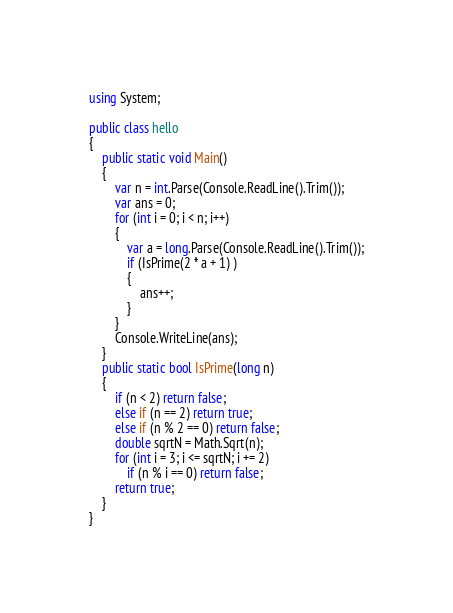Convert code to text. <code><loc_0><loc_0><loc_500><loc_500><_C#_>using System;

public class hello
{
    public static void Main()
    {
        var n = int.Parse(Console.ReadLine().Trim());
        var ans = 0;
        for (int i = 0; i < n; i++)
        {
            var a = long.Parse(Console.ReadLine().Trim());
            if (IsPrime(2 * a + 1) )
            {
                ans++;
            }
        }
        Console.WriteLine(ans);
    }
    public static bool IsPrime(long n)
    {
        if (n < 2) return false;
        else if (n == 2) return true;
        else if (n % 2 == 0) return false; 
        double sqrtN = Math.Sqrt(n);
        for (int i = 3; i <= sqrtN; i += 2)
            if (n % i == 0) return false;
        return true;
    }
}</code> 